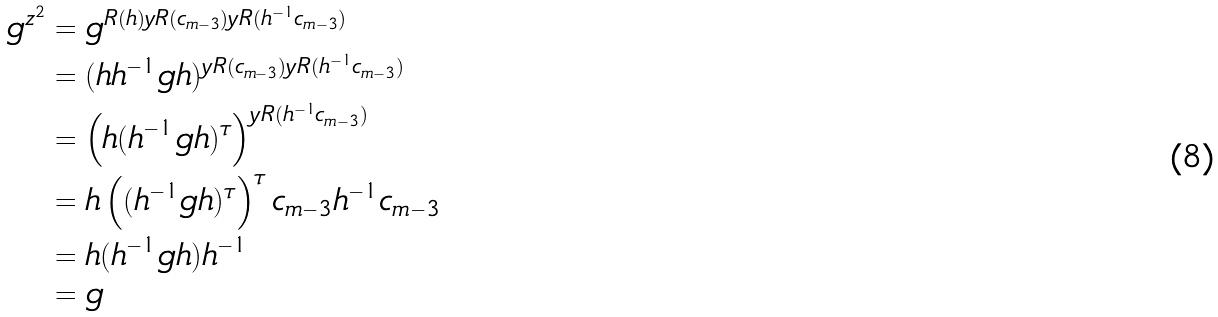<formula> <loc_0><loc_0><loc_500><loc_500>g ^ { z ^ { 2 } } & = g ^ { R ( h ) y R ( c _ { m - 3 } ) y R ( h ^ { - 1 } c _ { m - 3 } ) } \\ & = ( h h ^ { - 1 } g h ) ^ { y R ( c _ { m - 3 } ) y R ( h ^ { - 1 } c _ { m - 3 } ) } \\ & = \left ( h ( h ^ { - 1 } g h ) ^ { \tau } \right ) ^ { y R ( h ^ { - 1 } c _ { m - 3 } ) } \\ & = h \left ( ( h ^ { - 1 } g h ) ^ { \tau } \right ) ^ { \tau } c _ { m - 3 } h ^ { - 1 } c _ { m - 3 } \\ & = h ( h ^ { - 1 } g h ) h ^ { - 1 } \\ & = g</formula> 